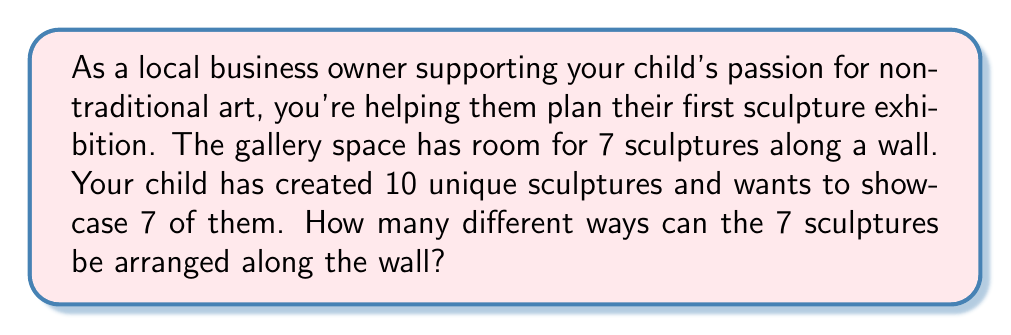Provide a solution to this math problem. To solve this problem, we need to break it down into two steps:

1. Choose 7 sculptures from the 10 available.
2. Arrange the chosen 7 sculptures along the wall.

Step 1: Choosing 7 sculptures from 10
This is a combination problem. We use the combination formula:

$${10 \choose 7} = \frac{10!}{7!(10-7)!} = \frac{10!}{7!(3)!}$$

Step 2: Arranging the chosen 7 sculptures
Once we have chosen 7 sculptures, we need to arrange them. This is a permutation of 7 items, which is simply 7!

Therefore, the total number of ways to arrange the sculptures is:

$$\text{Total arrangements} = {10 \choose 7} \times 7!$$

Let's calculate:

$${10 \choose 7} = \frac{10!}{7!(3)!} = \frac{10 \times 9 \times 8}{3 \times 2 \times 1} = 120$$

Now, we multiply by 7!:

$$120 \times 7! = 120 \times 5040 = 604,800$$

Thus, there are 604,800 different ways to arrange 7 sculptures chosen from 10 along the wall.
Answer: 604,800 different arrangements 